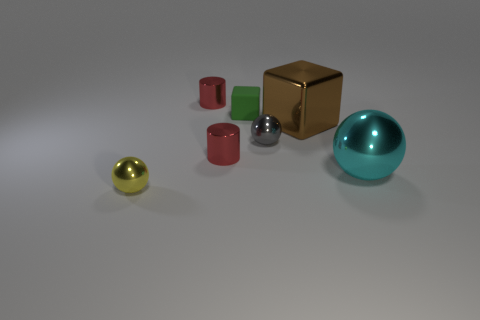Add 2 small cyan objects. How many objects exist? 9 Subtract all spheres. How many objects are left? 4 Subtract all small green matte objects. Subtract all red metal cylinders. How many objects are left? 4 Add 7 balls. How many balls are left? 10 Add 6 brown balls. How many brown balls exist? 6 Subtract 0 blue cylinders. How many objects are left? 7 